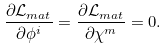Convert formula to latex. <formula><loc_0><loc_0><loc_500><loc_500>\frac { \partial \mathcal { L } _ { m a t } } { \partial \phi ^ { i } } = \frac { \partial \mathcal { L } _ { m a t } } { \partial \chi ^ { m } } = 0 .</formula> 